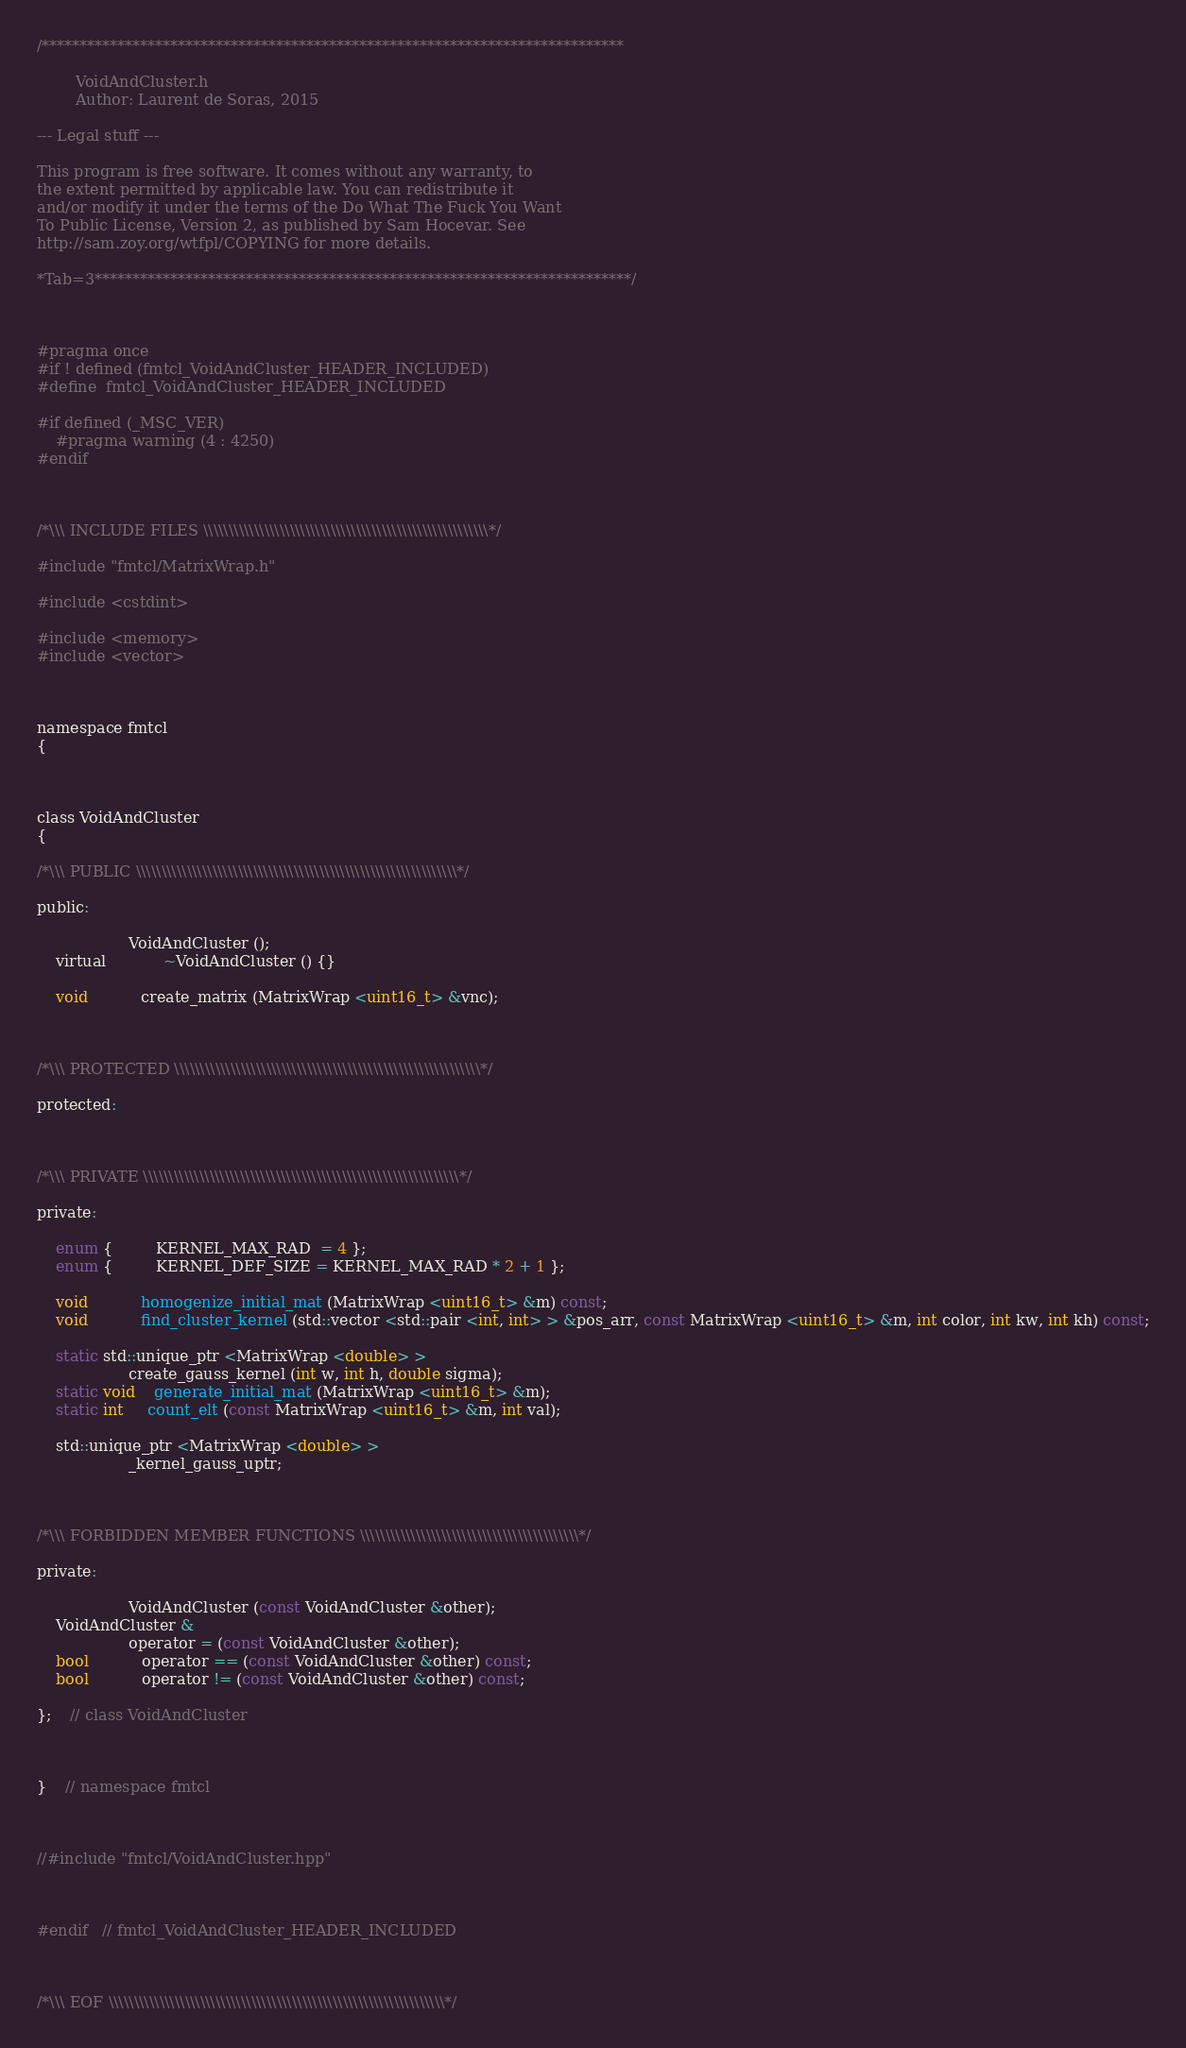<code> <loc_0><loc_0><loc_500><loc_500><_C_>/*****************************************************************************

        VoidAndCluster.h
        Author: Laurent de Soras, 2015

--- Legal stuff ---

This program is free software. It comes without any warranty, to
the extent permitted by applicable law. You can redistribute it
and/or modify it under the terms of the Do What The Fuck You Want
To Public License, Version 2, as published by Sam Hocevar. See
http://sam.zoy.org/wtfpl/COPYING for more details.

*Tab=3***********************************************************************/



#pragma once
#if ! defined (fmtcl_VoidAndCluster_HEADER_INCLUDED)
#define	fmtcl_VoidAndCluster_HEADER_INCLUDED

#if defined (_MSC_VER)
	#pragma warning (4 : 4250)
#endif



/*\\\ INCLUDE FILES \\\\\\\\\\\\\\\\\\\\\\\\\\\\\\\\\\\\\\\\\\\\\\\\\\\\\\\\*/

#include "fmtcl/MatrixWrap.h"

#include <cstdint>

#include <memory>
#include <vector>



namespace fmtcl
{



class VoidAndCluster
{

/*\\\ PUBLIC \\\\\\\\\\\\\\\\\\\\\\\\\\\\\\\\\\\\\\\\\\\\\\\\\\\\\\\\\\\\\\\*/

public:

	               VoidAndCluster ();
	virtual			~VoidAndCluster () {}

	void           create_matrix (MatrixWrap <uint16_t> &vnc);



/*\\\ PROTECTED \\\\\\\\\\\\\\\\\\\\\\\\\\\\\\\\\\\\\\\\\\\\\\\\\\\\\\\\\\\\*/

protected:



/*\\\ PRIVATE \\\\\\\\\\\\\\\\\\\\\\\\\\\\\\\\\\\\\\\\\\\\\\\\\\\\\\\\\\\\\\*/

private:

	enum {         KERNEL_MAX_RAD  = 4 };
	enum {         KERNEL_DEF_SIZE = KERNEL_MAX_RAD * 2 + 1 };

	void           homogenize_initial_mat (MatrixWrap <uint16_t> &m) const;
	void           find_cluster_kernel (std::vector <std::pair <int, int> > &pos_arr, const MatrixWrap <uint16_t> &m, int color, int kw, int kh) const;

	static std::unique_ptr <MatrixWrap <double> >
	               create_gauss_kernel (int w, int h, double sigma);
	static void    generate_initial_mat (MatrixWrap <uint16_t> &m);
	static int     count_elt (const MatrixWrap <uint16_t> &m, int val);

	std::unique_ptr <MatrixWrap <double> >
	               _kernel_gauss_uptr;



/*\\\ FORBIDDEN MEMBER FUNCTIONS \\\\\\\\\\\\\\\\\\\\\\\\\\\\\\\\\\\\\\\\\\\*/

private:

	               VoidAndCluster (const VoidAndCluster &other);
	VoidAndCluster &
	               operator = (const VoidAndCluster &other);
	bool           operator == (const VoidAndCluster &other) const;
	bool           operator != (const VoidAndCluster &other) const;

};	// class VoidAndCluster



}	// namespace fmtcl



//#include "fmtcl/VoidAndCluster.hpp"



#endif	// fmtcl_VoidAndCluster_HEADER_INCLUDED



/*\\\ EOF \\\\\\\\\\\\\\\\\\\\\\\\\\\\\\\\\\\\\\\\\\\\\\\\\\\\\\\\\\\\\\\\\\*/
</code> 